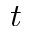Convert formula to latex. <formula><loc_0><loc_0><loc_500><loc_500>t</formula> 